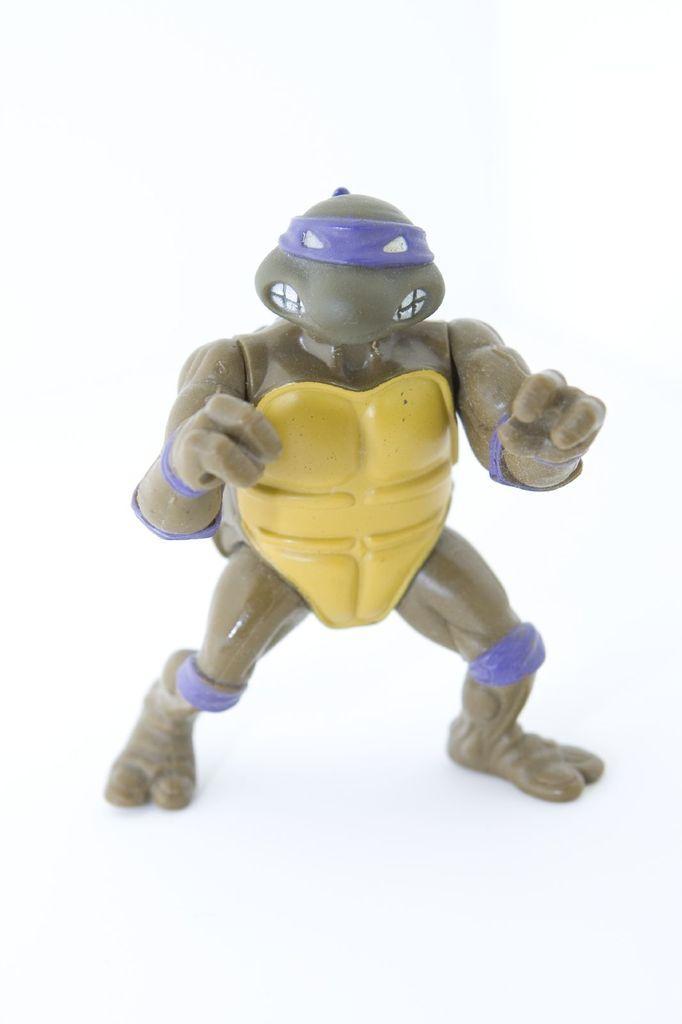Could you give a brief overview of what you see in this image? In this image there is a person standing by holding the object. 